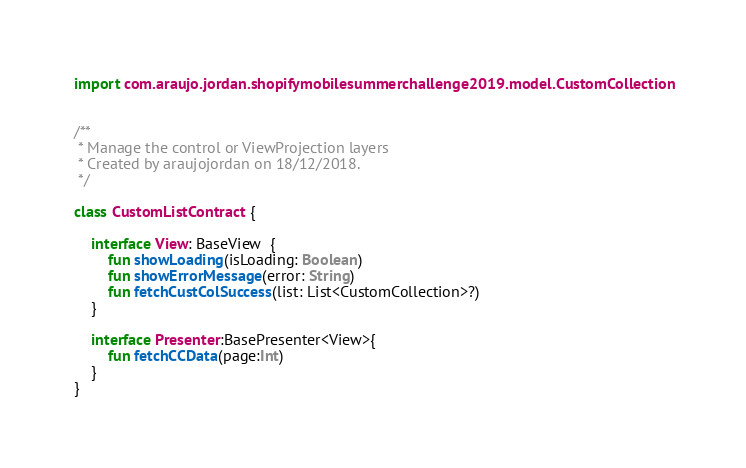Convert code to text. <code><loc_0><loc_0><loc_500><loc_500><_Kotlin_>import com.araujo.jordan.shopifymobilesummerchallenge2019.model.CustomCollection


/**
 * Manage the control or ViewProjection layers
 * Created by araujojordan on 18/12/2018.
 */

class CustomListContract {

    interface View: BaseView  {
        fun showLoading(isLoading: Boolean)
        fun showErrorMessage(error: String)
        fun fetchCustColSuccess(list: List<CustomCollection>?)
    }

    interface Presenter:BasePresenter<View>{
        fun fetchCCData(page:Int)
    }
}</code> 